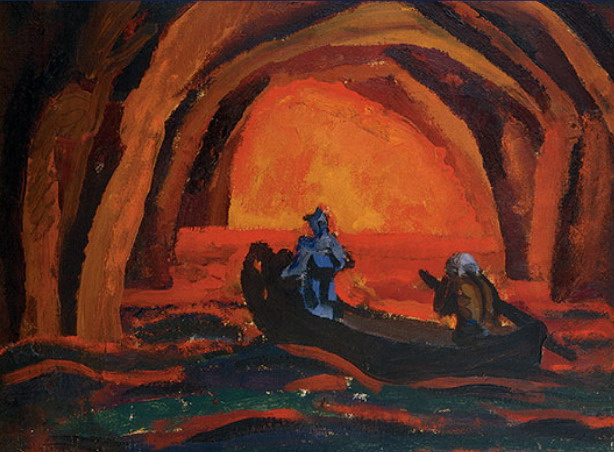Can you describe the emotions conveyed by the colors used in this image? The warm, fiery colors of the cave suggest an atmosphere of mystery and wonder, potentially reflective of the figures' emotional journey. In stark contrast, the cool blues of the boat and its occupants impart a sense of calm and introspection. The juxtaposition of these hues creates a dynamic visual narrative that pulls the viewer into a contemplative state, pondering the deeper meaning behind the journey. 